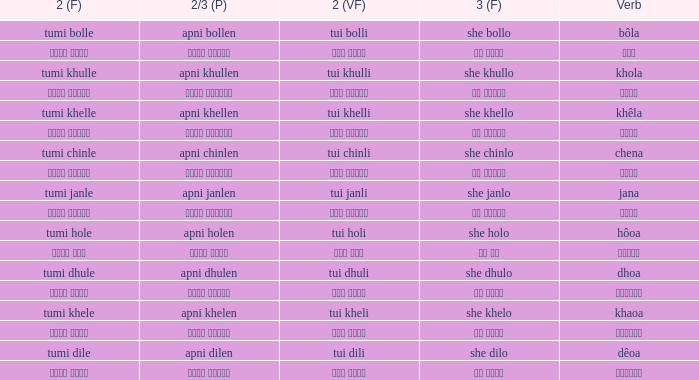What is the 2nd verb for chena? Tumi chinle. Would you mind parsing the complete table? {'header': ['2 (F)', '2/3 (P)', '2 (VF)', '3 (F)', 'Verb'], 'rows': [['tumi bolle', 'apni bollen', 'tui bolli', 'she bollo', 'bôla'], ['তুমি বললে', 'আপনি বললেন', 'তুই বললি', 'সে বললো', 'বলা'], ['tumi khulle', 'apni khullen', 'tui khulli', 'she khullo', 'khola'], ['তুমি খুললে', 'আপনি খুললেন', 'তুই খুললি', 'সে খুললো', 'খোলা'], ['tumi khelle', 'apni khellen', 'tui khelli', 'she khello', 'khêla'], ['তুমি খেললে', 'আপনি খেললেন', 'তুই খেললি', 'সে খেললো', 'খেলে'], ['tumi chinle', 'apni chinlen', 'tui chinli', 'she chinlo', 'chena'], ['তুমি চিনলে', 'আপনি চিনলেন', 'তুই চিনলি', 'সে চিনলো', 'চেনা'], ['tumi janle', 'apni janlen', 'tui janli', 'she janlo', 'jana'], ['তুমি জানলে', 'আপনি জানলেন', 'তুই জানলি', 'সে জানলে', 'জানা'], ['tumi hole', 'apni holen', 'tui holi', 'she holo', 'hôoa'], ['তুমি হলে', 'আপনি হলেন', 'তুই হলি', 'সে হল', 'হওয়া'], ['tumi dhule', 'apni dhulen', 'tui dhuli', 'she dhulo', 'dhoa'], ['তুমি ধুলে', 'আপনি ধুলেন', 'তুই ধুলি', 'সে ধুলো', 'ধোওয়া'], ['tumi khele', 'apni khelen', 'tui kheli', 'she khelo', 'khaoa'], ['তুমি খেলে', 'আপনি খেলেন', 'তুই খেলি', 'সে খেলো', 'খাওয়া'], ['tumi dile', 'apni dilen', 'tui dili', 'she dilo', 'dêoa'], ['তুমি দিলে', 'আপনি দিলেন', 'তুই দিলি', 'সে দিলো', 'দেওয়া']]} 